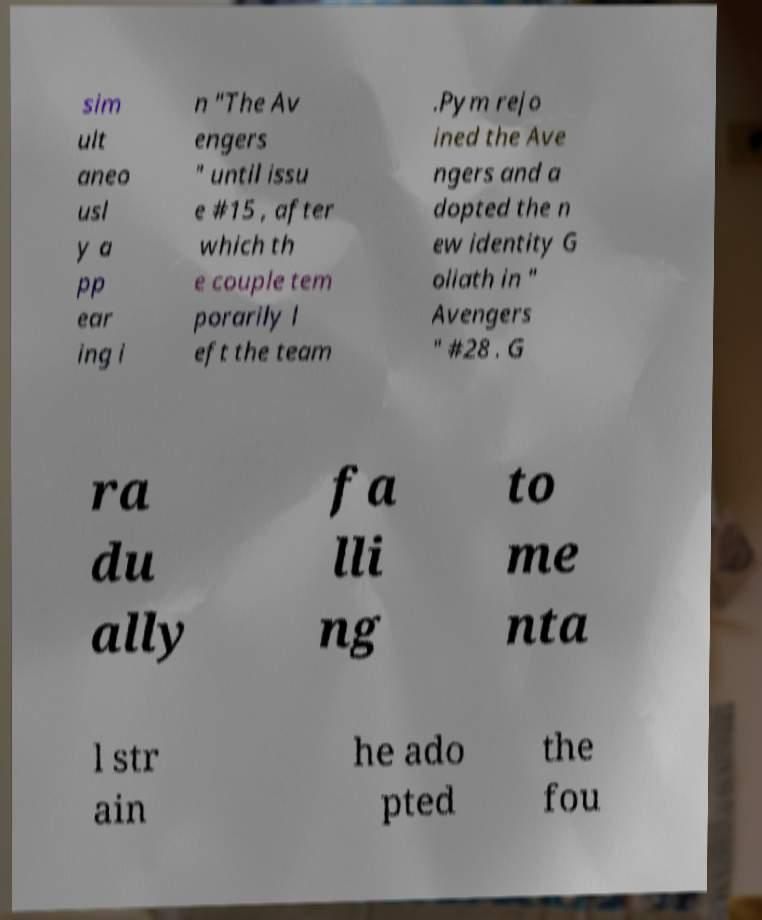Could you extract and type out the text from this image? sim ult aneo usl y a pp ear ing i n "The Av engers " until issu e #15 , after which th e couple tem porarily l eft the team .Pym rejo ined the Ave ngers and a dopted the n ew identity G oliath in " Avengers " #28 . G ra du ally fa lli ng to me nta l str ain he ado pted the fou 